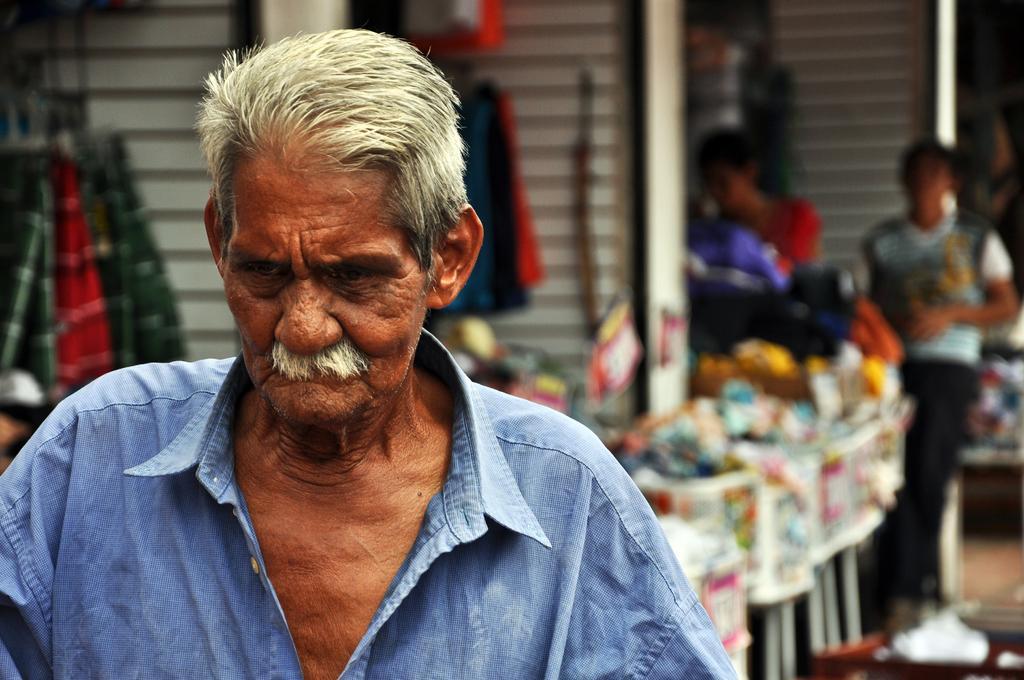In one or two sentences, can you explain what this image depicts? In the image I can see a person who is standing in front of the table on which there are some things placed and also I can see some other people. 